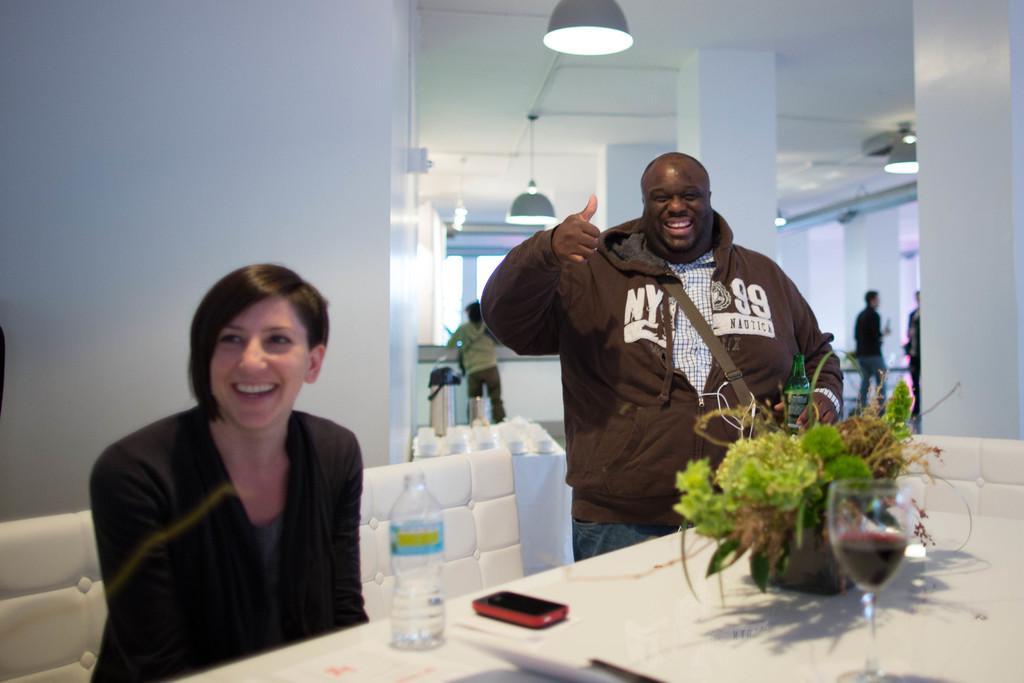How would you summarize this image in a sentence or two? In this picture we can see couple of people, a woman is seated on the chair, next to her we can see a man, he is holding a bottle in his hand and they both are smiling, in front of them we can find a bottle, mobile, flower pot and a glass on the table, in the background we can see couple of lights. 